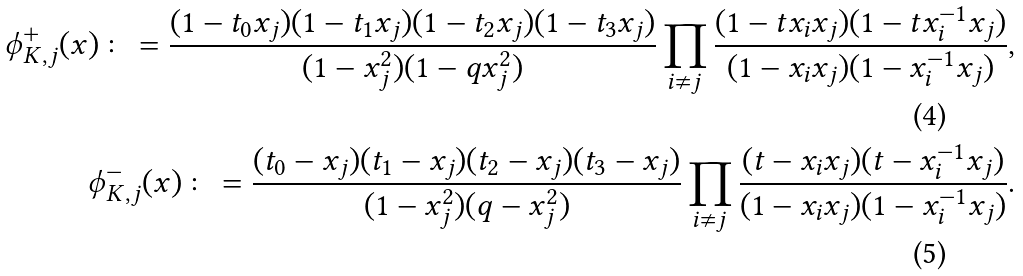Convert formula to latex. <formula><loc_0><loc_0><loc_500><loc_500>\phi _ { K , j } ^ { + } ( x ) \colon = \frac { ( 1 - t _ { 0 } x _ { j } ) ( 1 - t _ { 1 } x _ { j } ) ( 1 - t _ { 2 } x _ { j } ) ( 1 - t _ { 3 } x _ { j } ) } { ( 1 - x _ { j } ^ { 2 } ) ( 1 - q x _ { j } ^ { 2 } ) } \prod _ { i \neq j } \frac { ( 1 - t x _ { i } x _ { j } ) ( 1 - t x _ { i } ^ { - 1 } x _ { j } ) } { ( 1 - x _ { i } x _ { j } ) ( 1 - x _ { i } ^ { - 1 } x _ { j } ) } , \\ \phi _ { K , j } ^ { - } ( x ) \colon = \frac { ( t _ { 0 } - x _ { j } ) ( t _ { 1 } - x _ { j } ) ( t _ { 2 } - x _ { j } ) ( t _ { 3 } - x _ { j } ) } { ( 1 - x _ { j } ^ { 2 } ) ( q - x _ { j } ^ { 2 } ) } \prod _ { i \neq j } \frac { ( t - x _ { i } x _ { j } ) ( t - x _ { i } ^ { - 1 } x _ { j } ) } { ( 1 - x _ { i } x _ { j } ) ( 1 - x _ { i } ^ { - 1 } x _ { j } ) } .</formula> 